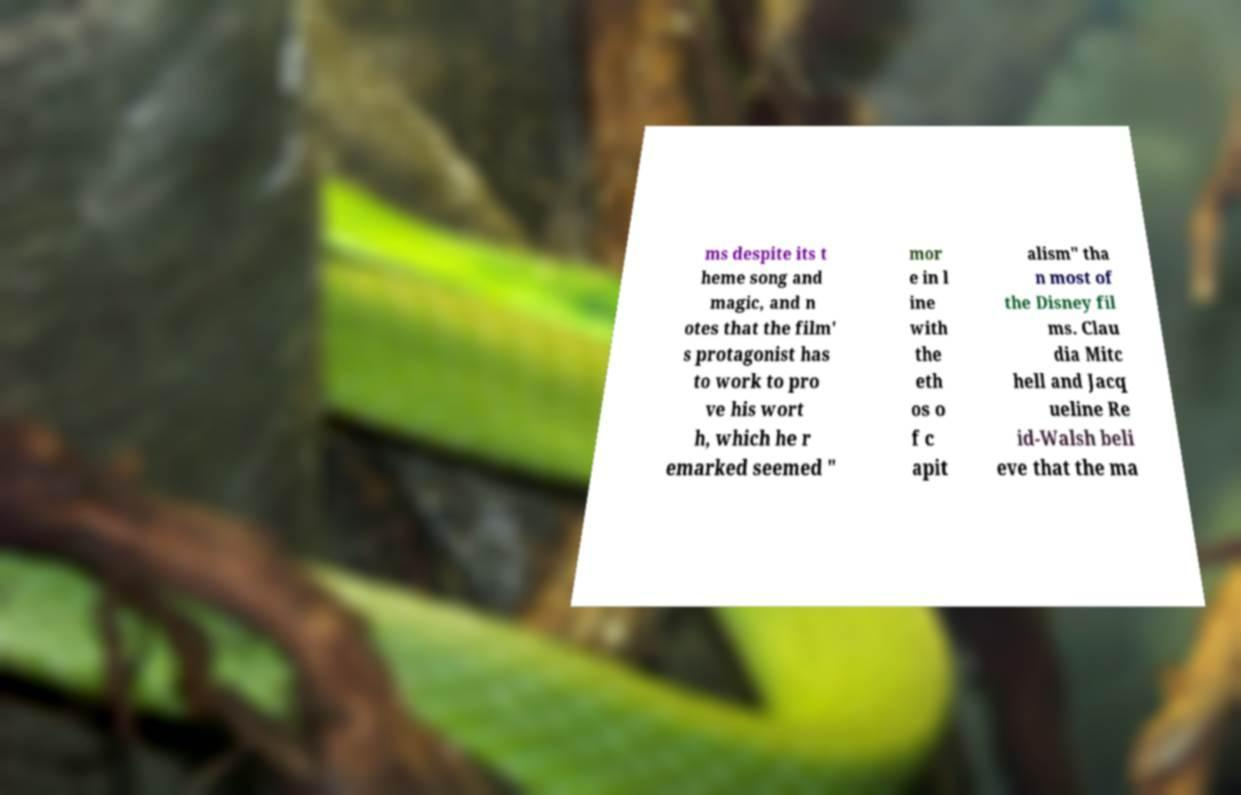Please identify and transcribe the text found in this image. ms despite its t heme song and magic, and n otes that the film' s protagonist has to work to pro ve his wort h, which he r emarked seemed " mor e in l ine with the eth os o f c apit alism" tha n most of the Disney fil ms. Clau dia Mitc hell and Jacq ueline Re id-Walsh beli eve that the ma 